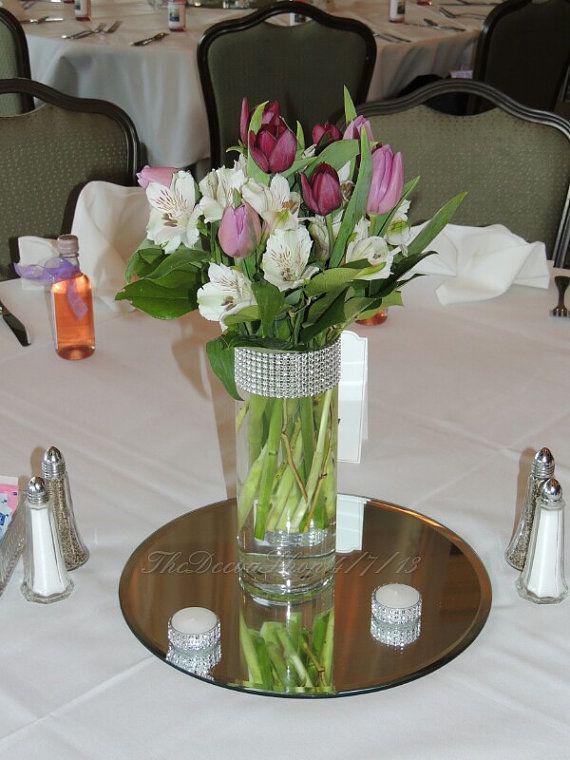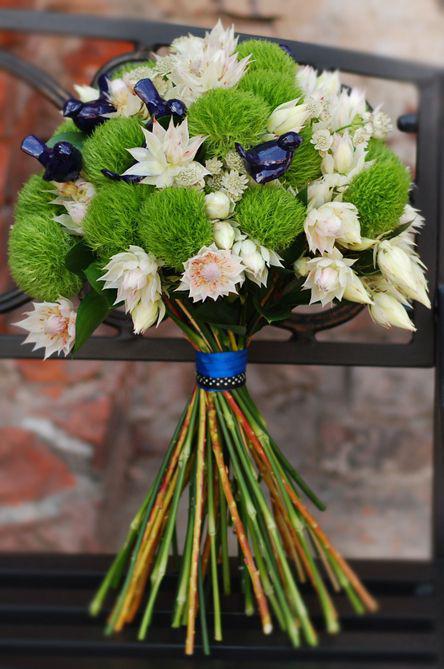The first image is the image on the left, the second image is the image on the right. Analyze the images presented: Is the assertion "There are flowers in a transparent vase in the image on the right." valid? Answer yes or no. No. 